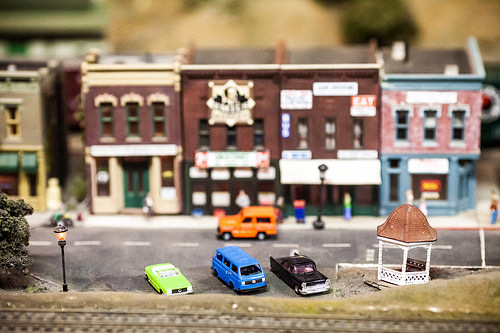<image>
Is there a van to the right of the gazebo? No. The van is not to the right of the gazebo. The horizontal positioning shows a different relationship. Where is the car in relation to the car? Is it above the car? No. The car is not positioned above the car. The vertical arrangement shows a different relationship. 